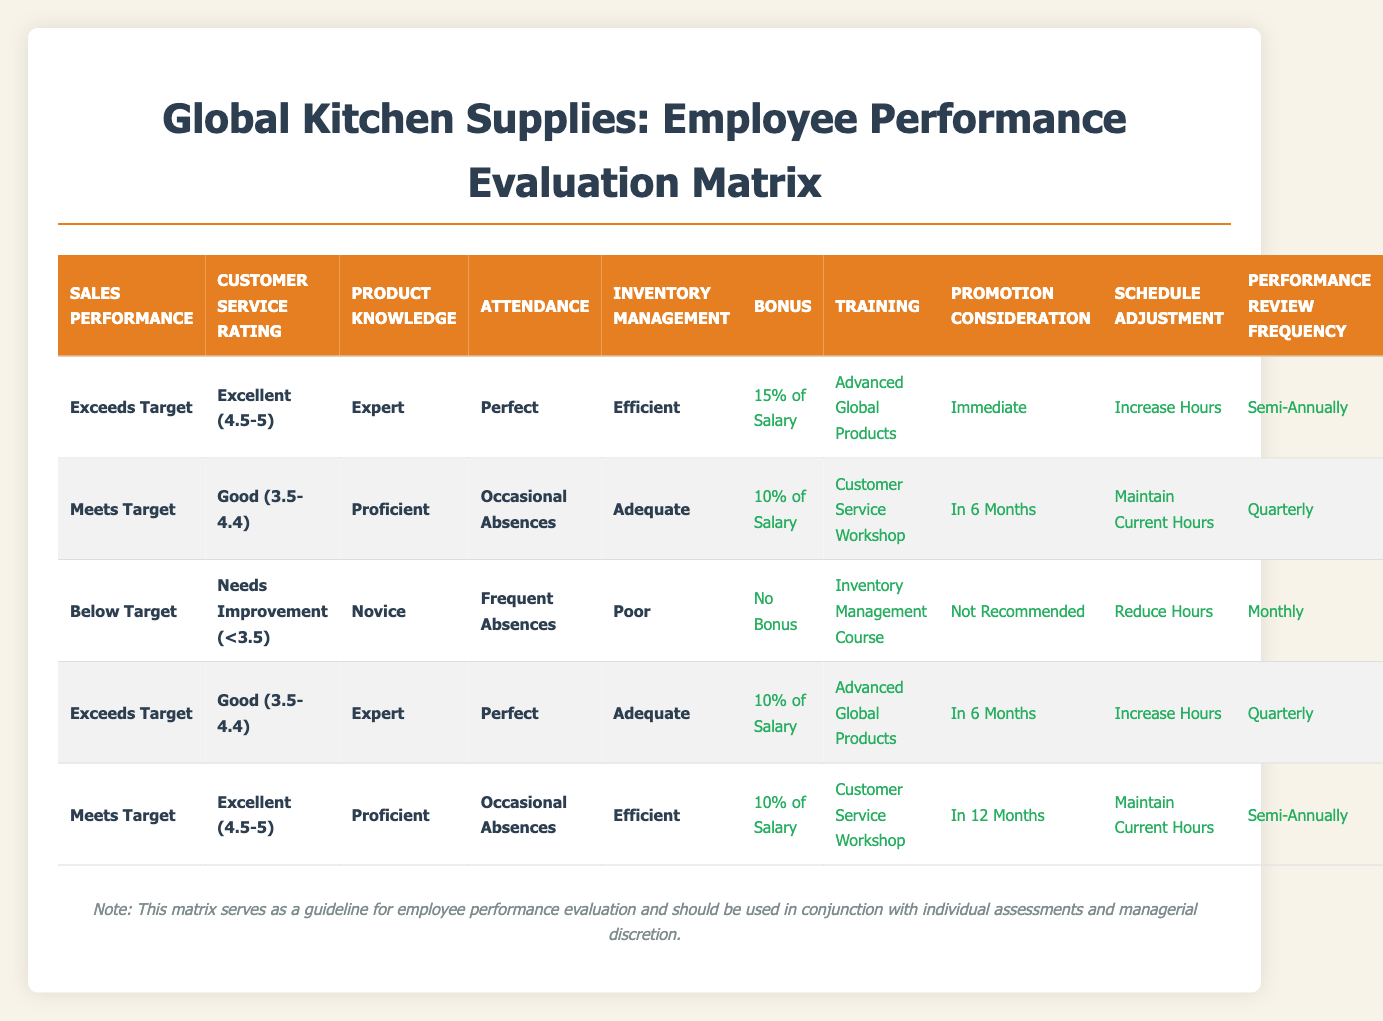What is the bonus percentage for employees who exceed targets and have perfect attendance? According to the table, for employees categorized as "Exceeds Target" with "Perfect" attendance, the bonus is "15% of Salary."
Answer: 15% of Salary How many training types are recommended for employees with below-target performance? There is one training type recommended for employees with below-target performance, which is "Inventory Management Course."
Answer: 1 Are employees with good customer service ratings who meet their sales targets scheduled for monthly performance reviews? Employees who meet their sales targets and have good customer service ratings have "Quarterly" performance reviews, not monthly.
Answer: No What actions are taken for an employee who meets targets, has occasional absences, and proficient product knowledge? Employees who meet targets, have occasional absences, and proficient product knowledge receive a "10% of Salary" bonus, "Customer Service Workshop" training, "In 6 Months" for promotion consideration, "Maintain Current Hours" for schedule adjustment, and "Quarterly" performance review frequency.
Answer: 10% of Salary What is the most common training action recommended across all performance levels in the matrix? The "Customer Service Workshop" appears for both "Meets Target" employees with various attendance and performance metrics, making it the most common training action in the provided rules.
Answer: Customer Service Workshop For employees who exceed targets and have frequent absences, what would be their performance review frequency? There is no rule that suggests employees exceeding targets would have frequent absences. However, if they did, a review would be challenging to define based on existing data. Thus, this specific scenario is not covered, leading to potential misunderstanding.
Answer: Not applicable How does the promotion consideration differ for employees who exceed targets versus those who meet targets with excellent customer service ratings? For employees exceeding targets, the promotion consideration is "Immediate," while for those who meet targets with excellent ratings, it is "In 12 Months."
Answer: Immediate vs. In 12 Months If an employee is a novice, has frequent absences, and is below target, what actions are prescribed? The table indicates that for a novice employee who is below target and has frequent absences, the actions would be "No Bonus," "Inventory Management Course," "Not Recommended" for promotion, "Reduce Hours," and "Monthly" for performance reviews.
Answer: No Bonus, Inventory Management Course, Not Recommended, Reduce Hours, Monthly Is it true that all employees who exceed targets receive a bonus? All employees exceeding targets receive a bonus according to the rules defined.
Answer: Yes 